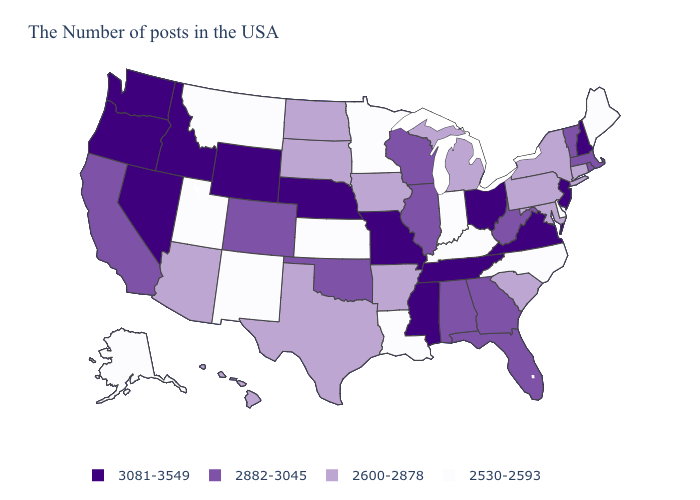Does Ohio have a higher value than Alabama?
Keep it brief. Yes. Name the states that have a value in the range 3081-3549?
Concise answer only. New Hampshire, New Jersey, Virginia, Ohio, Tennessee, Mississippi, Missouri, Nebraska, Wyoming, Idaho, Nevada, Washington, Oregon. Does the map have missing data?
Answer briefly. No. Does the map have missing data?
Be succinct. No. What is the highest value in the USA?
Short answer required. 3081-3549. What is the value of Tennessee?
Quick response, please. 3081-3549. What is the value of Oklahoma?
Keep it brief. 2882-3045. Which states have the highest value in the USA?
Write a very short answer. New Hampshire, New Jersey, Virginia, Ohio, Tennessee, Mississippi, Missouri, Nebraska, Wyoming, Idaho, Nevada, Washington, Oregon. What is the highest value in states that border Delaware?
Give a very brief answer. 3081-3549. What is the lowest value in states that border Connecticut?
Quick response, please. 2600-2878. What is the lowest value in states that border New Jersey?
Give a very brief answer. 2530-2593. Name the states that have a value in the range 2530-2593?
Give a very brief answer. Maine, Delaware, North Carolina, Kentucky, Indiana, Louisiana, Minnesota, Kansas, New Mexico, Utah, Montana, Alaska. What is the lowest value in the MidWest?
Concise answer only. 2530-2593. Which states hav the highest value in the MidWest?
Quick response, please. Ohio, Missouri, Nebraska. What is the lowest value in the USA?
Concise answer only. 2530-2593. 